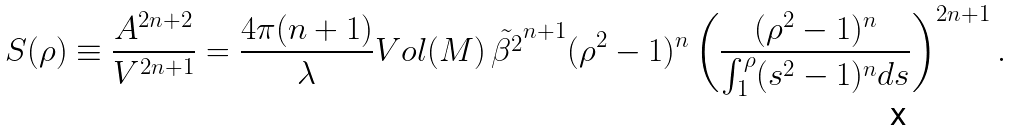Convert formula to latex. <formula><loc_0><loc_0><loc_500><loc_500>S ( \rho ) \equiv \frac { A ^ { 2 n + 2 } } { V ^ { 2 n + 1 } } = \frac { 4 \pi ( n + 1 ) } { \lambda } V o l ( M ) \, \tilde { \beta ^ { 2 } } ^ { n + 1 } ( \rho ^ { 2 } - 1 ) ^ { n } \left ( \frac { ( \rho ^ { 2 } - 1 ) ^ { n } } { \int _ { 1 } ^ { \rho } ( s ^ { 2 } - 1 ) ^ { n } d s } \right ) ^ { 2 n + 1 } .</formula> 